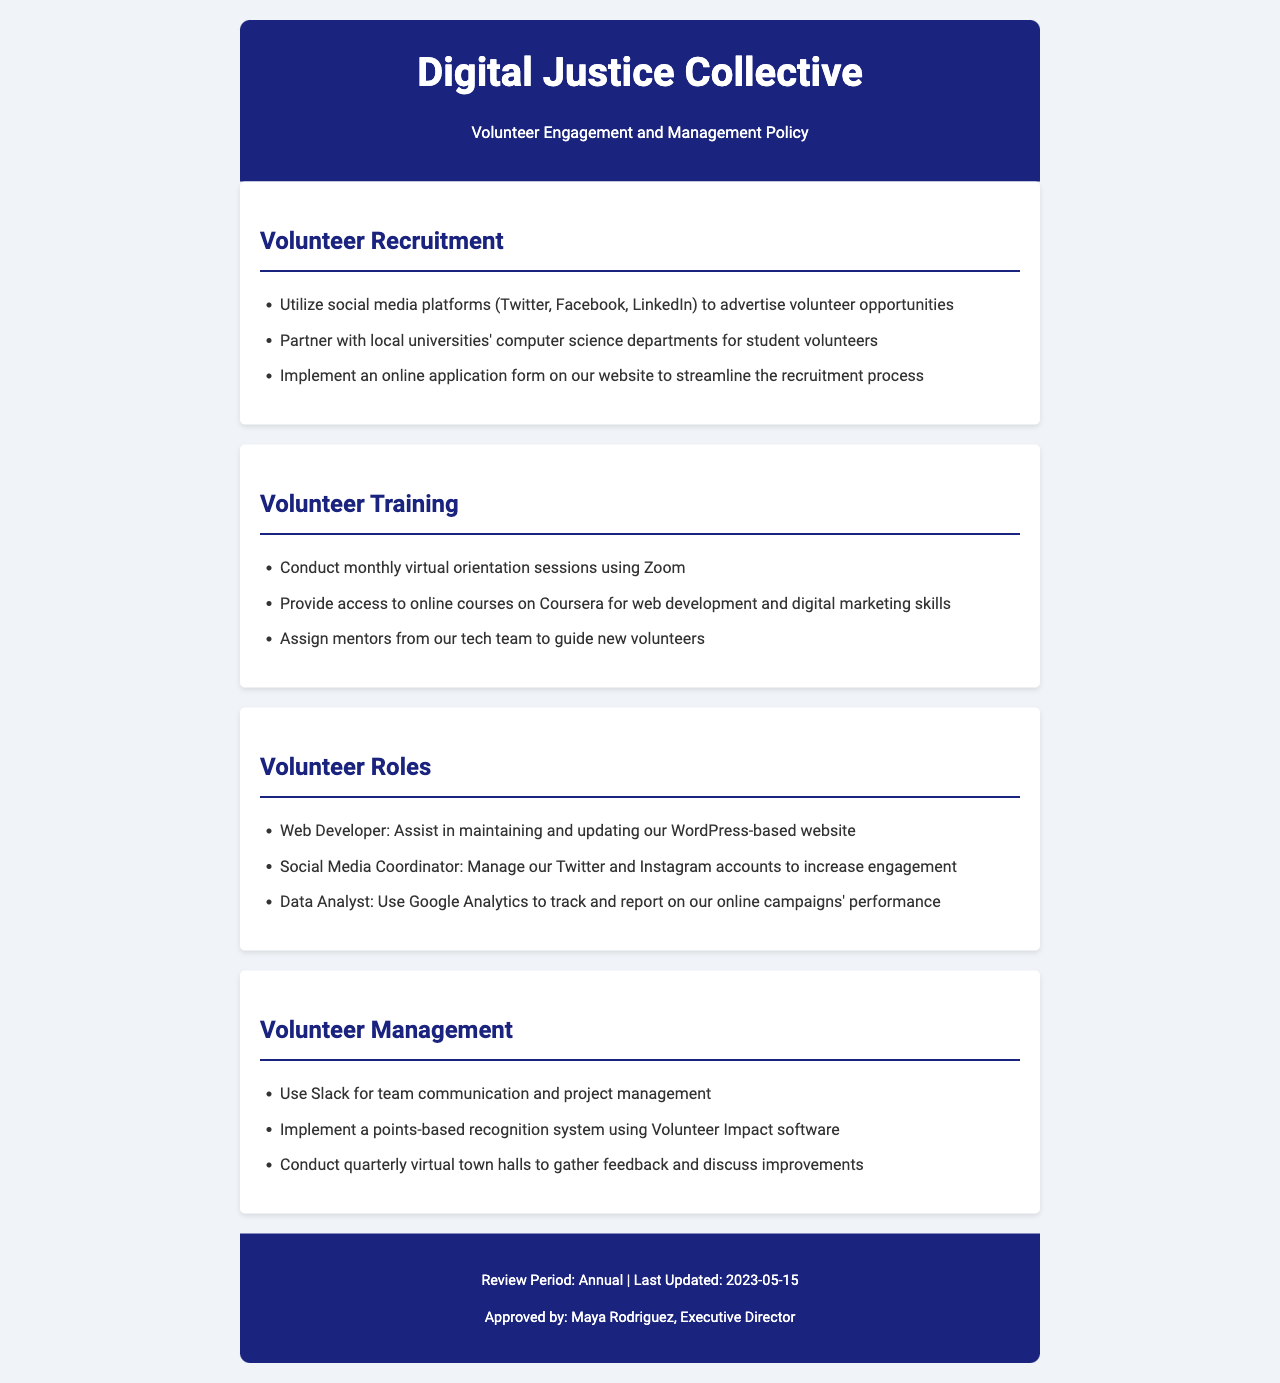What platforms are used for volunteer recruitment? The document lists social media platforms including Twitter, Facebook, and LinkedIn among others for volunteer recruitment.
Answer: Twitter, Facebook, LinkedIn What is the online tool used for managing team communication? The document states that Slack is used for team communication and project management.
Answer: Slack How often are virtual orientation sessions conducted? According to the document, monthly virtual orientation sessions are conducted.
Answer: Monthly Who is responsible for mentoring new volunteers? The document mentions that mentors will be assigned from the tech team to guide new volunteers.
Answer: Tech team What role assists in maintaining the website? The document specifies that a Web Developer assists in maintaining and updating the website.
Answer: Web Developer What online course platform is provided for volunteer training? The document specifies Coursera as the platform providing access to online courses.
Answer: Coursera When was the document last updated? The document states that it was last updated on May 15, 2023.
Answer: May 15, 2023 What software is used for the recognition system? The document mentions that Volunteer Impact software is used for the recognition system.
Answer: Volunteer Impact How frequently are virtual town halls conducted? According to the document, virtual town halls are conducted quarterly.
Answer: Quarterly 